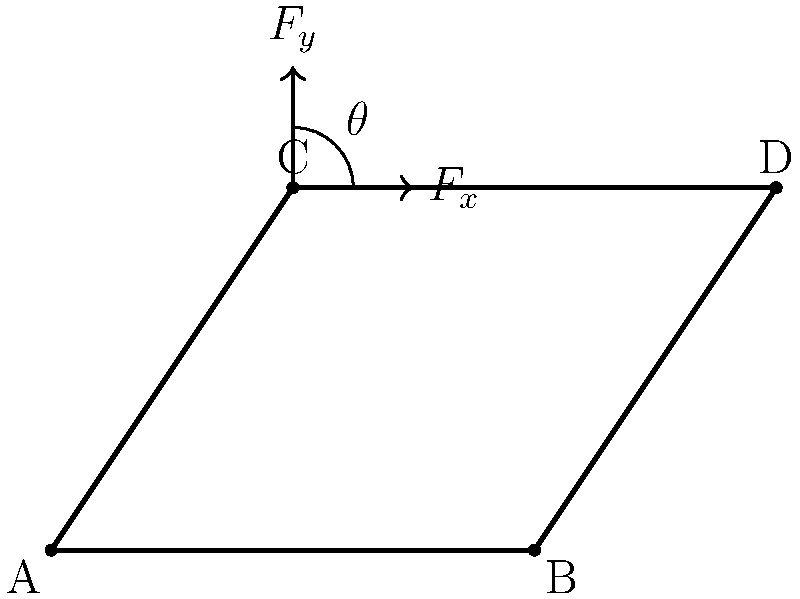In the context of Latin American revolutionary movements, consider the following analogy: The force analysis of a simple linkage mechanism can be compared to the distribution of power in a revolutionary organization. Given the linkage ABCD shown in the figure, where link AB is fixed horizontally, and a force F is applied at point C, determine the angle θ at which the vertical component of the force (F_y) is equal to the horizontal component (F_x). How might this relate to the balance of power in revolutionary groups? To solve this problem, we'll follow these steps:

1. Understand the force balance:
   For the vertical and horizontal components to be equal, we need:
   $$F_y = F_x$$

2. Express the components in terms of the total force F and angle θ:
   $$F_x = F \cos(\theta)$$
   $$F_y = F \sin(\theta)$$

3. Set up the equation:
   $$F \sin(\theta) = F \cos(\theta)$$

4. Simplify by dividing both sides by F:
   $$\sin(\theta) = \cos(\theta)$$

5. Recall the trigonometric identity for when sine equals cosine:
   This occurs when θ = 45°

6. Interpret the result:
   The angle at which the vertical and horizontal components are equal is 45°. This represents a balance between the two force directions.

Relating to revolutionary groups:
This balance can be analogous to the equilibrium between different factions or ideologies within a revolutionary movement. Just as the linkage finds stability at 45°, revolutionary groups might seek a balance between various power structures or ideological positions to maintain cohesion and effectiveness.
Answer: 45° 